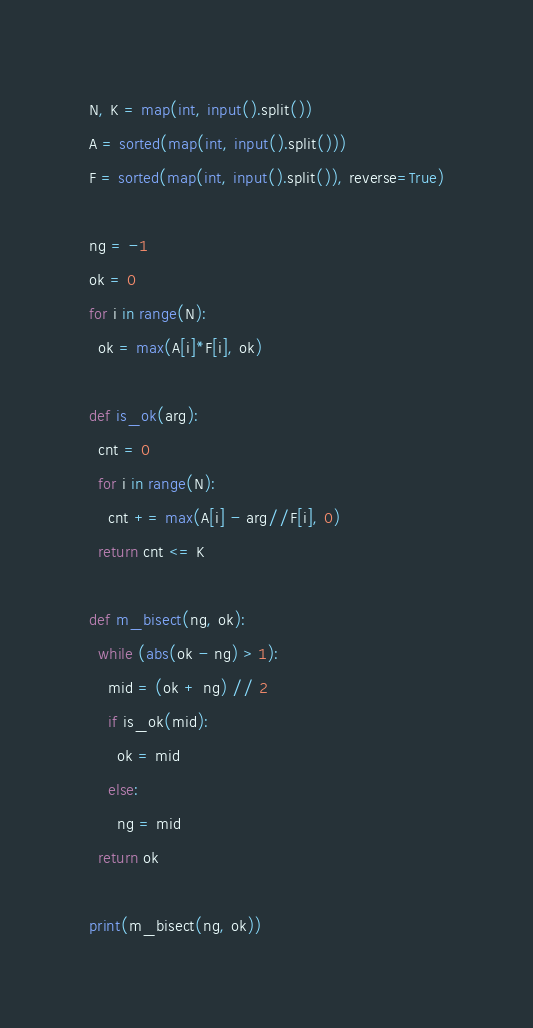Convert code to text. <code><loc_0><loc_0><loc_500><loc_500><_Python_>N, K = map(int, input().split())
A = sorted(map(int, input().split()))
F = sorted(map(int, input().split()), reverse=True)

ng = -1
ok = 0
for i in range(N):
  ok = max(A[i]*F[i], ok)

def is_ok(arg):
  cnt = 0
  for i in range(N):
    cnt += max(A[i] - arg//F[i], 0)
  return cnt <= K

def m_bisect(ng, ok):
  while (abs(ok - ng) > 1):
    mid = (ok + ng) // 2
    if is_ok(mid):
      ok = mid
    else:
      ng = mid
  return ok

print(m_bisect(ng, ok))</code> 